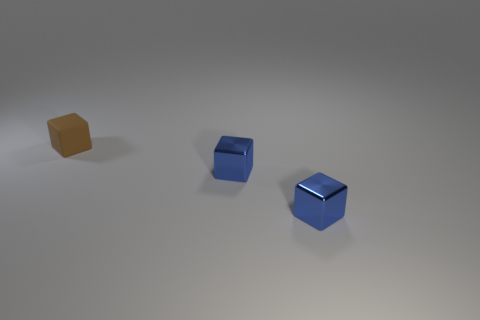What size is the brown thing?
Give a very brief answer. Small. There is a brown object; are there any small brown cubes to the right of it?
Your answer should be compact. No. What number of metal things are either small brown objects or blocks?
Offer a very short reply. 2. What number of things are either cubes to the right of the small brown matte cube or small cubes that are right of the small matte thing?
Your answer should be compact. 2. Are there any other things that are the same color as the tiny rubber cube?
Provide a short and direct response. No. How many other things are the same size as the matte object?
Provide a succinct answer. 2. What is the material of the small brown object?
Your response must be concise. Rubber. Are there more tiny brown matte objects in front of the brown rubber cube than tiny blue cubes?
Ensure brevity in your answer.  No. Is there a purple metal cube?
Offer a terse response. No. How many other objects are there of the same shape as the brown rubber thing?
Ensure brevity in your answer.  2. 